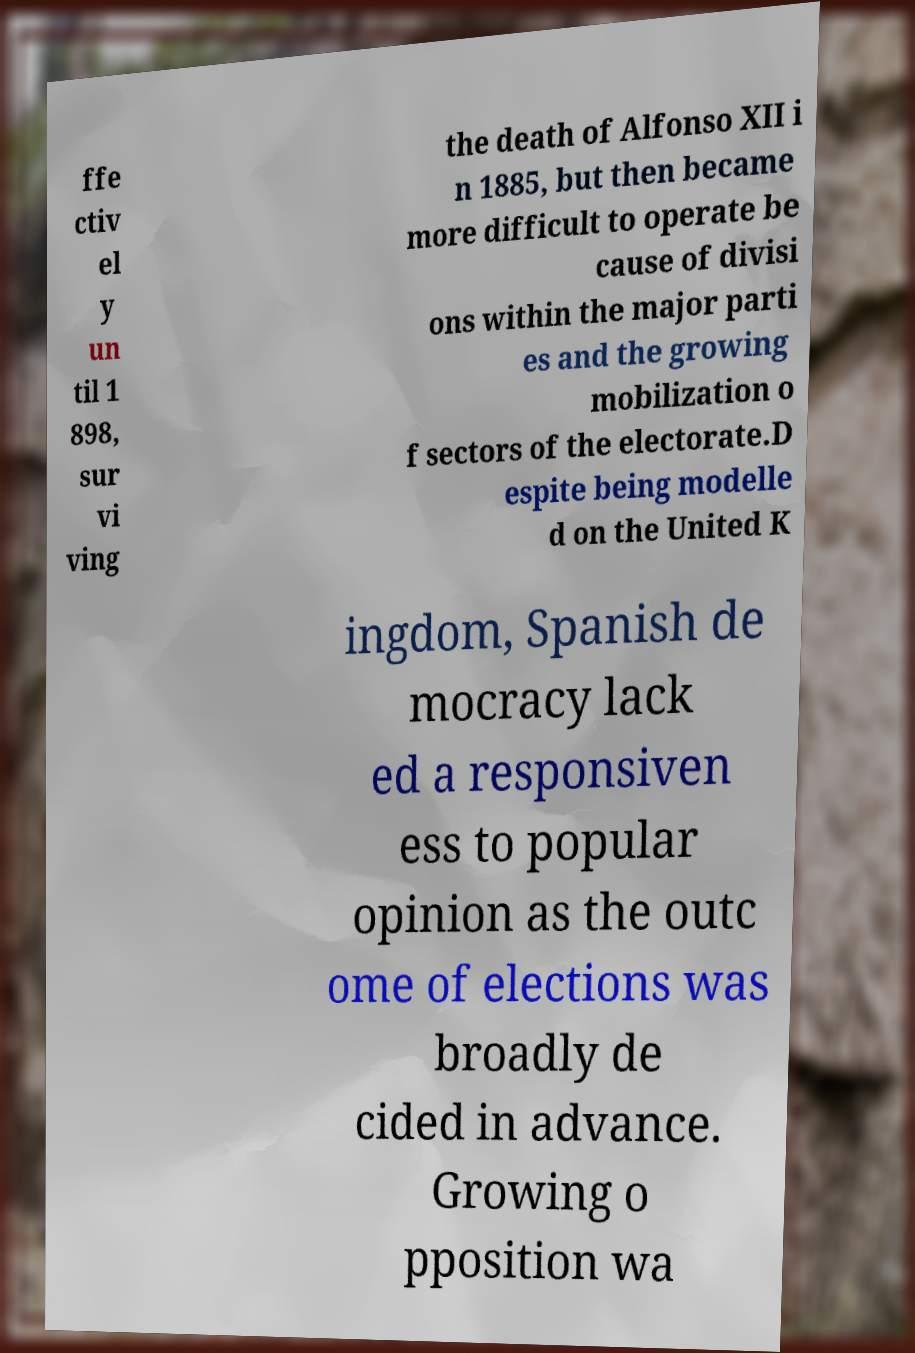Please read and relay the text visible in this image. What does it say? ffe ctiv el y un til 1 898, sur vi ving the death of Alfonso XII i n 1885, but then became more difficult to operate be cause of divisi ons within the major parti es and the growing mobilization o f sectors of the electorate.D espite being modelle d on the United K ingdom, Spanish de mocracy lack ed a responsiven ess to popular opinion as the outc ome of elections was broadly de cided in advance. Growing o pposition wa 